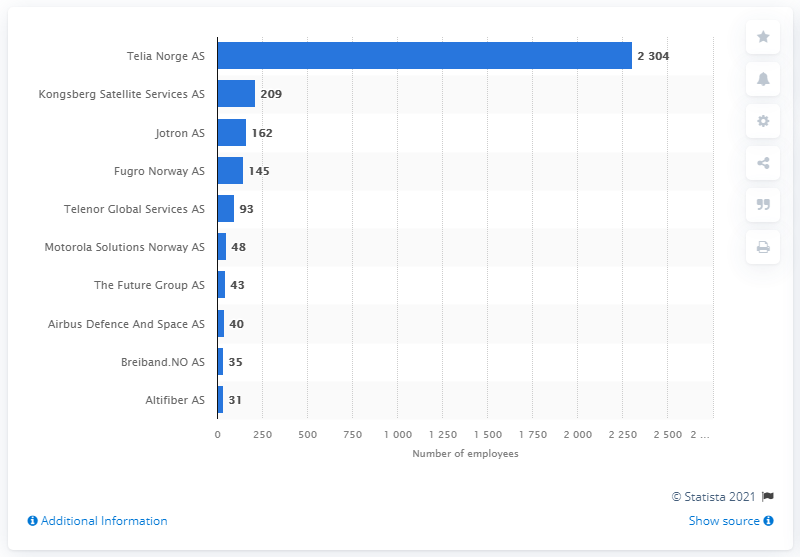Specify some key components in this picture. Kongsberg Satellite Services AS, which was ranked second with 209 employees, was a company known for its expertise in satellite services. Telia Norge AS was the leading telecommunication company as of June 2021. 